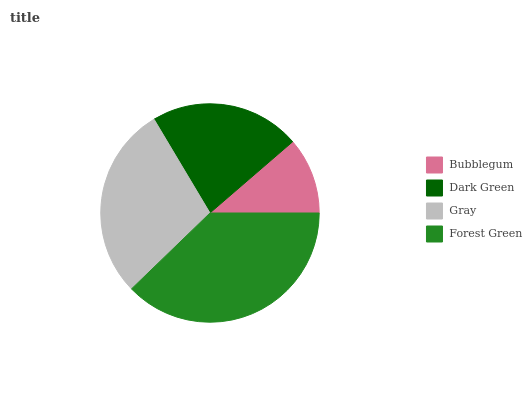Is Bubblegum the minimum?
Answer yes or no. Yes. Is Forest Green the maximum?
Answer yes or no. Yes. Is Dark Green the minimum?
Answer yes or no. No. Is Dark Green the maximum?
Answer yes or no. No. Is Dark Green greater than Bubblegum?
Answer yes or no. Yes. Is Bubblegum less than Dark Green?
Answer yes or no. Yes. Is Bubblegum greater than Dark Green?
Answer yes or no. No. Is Dark Green less than Bubblegum?
Answer yes or no. No. Is Gray the high median?
Answer yes or no. Yes. Is Dark Green the low median?
Answer yes or no. Yes. Is Dark Green the high median?
Answer yes or no. No. Is Gray the low median?
Answer yes or no. No. 